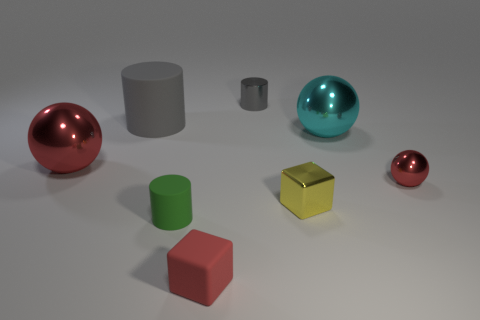Are there any matte cubes of the same size as the yellow object?
Your response must be concise. Yes. Are there the same number of cubes in front of the small green object and cyan matte spheres?
Your response must be concise. No. How big is the cyan shiny sphere?
Make the answer very short. Large. What number of tiny yellow metallic blocks are behind the block that is on the right side of the gray metallic object?
Provide a short and direct response. 0. There is a tiny metallic thing that is both to the left of the tiny red ball and in front of the big gray matte cylinder; what shape is it?
Make the answer very short. Cube. What number of big matte things have the same color as the tiny shiny cylinder?
Give a very brief answer. 1. There is a small red thing in front of the shiny thing to the right of the big cyan metal ball; is there a small yellow shiny object in front of it?
Your answer should be compact. No. There is a metal object that is both to the left of the tiny yellow metal object and in front of the big rubber cylinder; how big is it?
Keep it short and to the point. Large. How many yellow things have the same material as the tiny green thing?
Provide a short and direct response. 0. How many cylinders are either tiny objects or tiny green rubber things?
Make the answer very short. 2. 